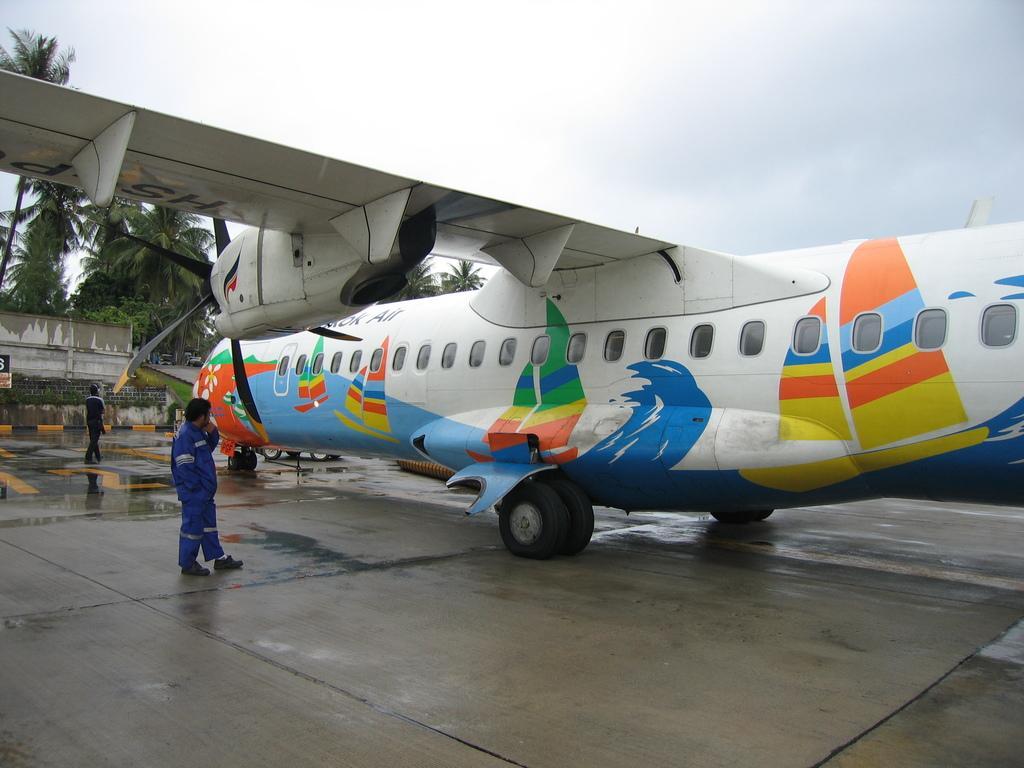Please provide a concise description of this image. In this image I can see a plane on the ground and a man is standing on the left and there are some trees on the left side. 